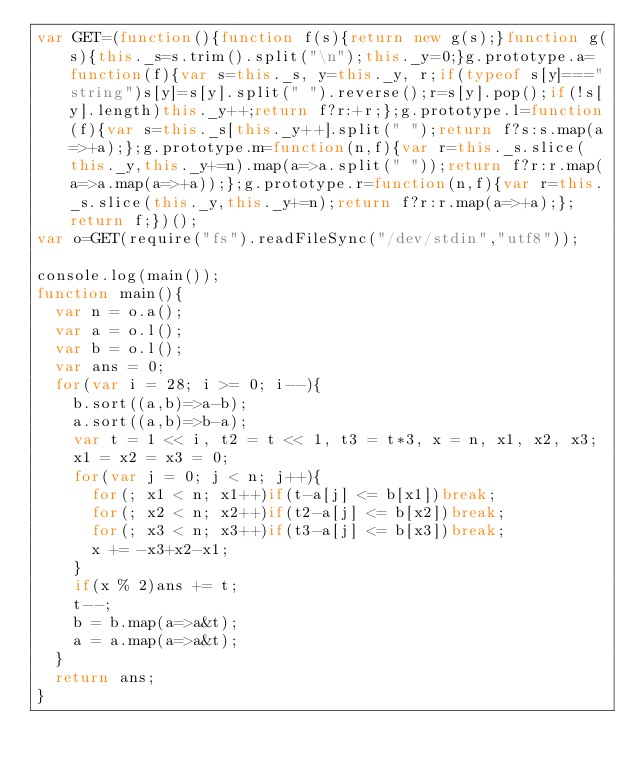Convert code to text. <code><loc_0><loc_0><loc_500><loc_500><_JavaScript_>var GET=(function(){function f(s){return new g(s);}function g(s){this._s=s.trim().split("\n");this._y=0;}g.prototype.a=function(f){var s=this._s, y=this._y, r;if(typeof s[y]==="string")s[y]=s[y].split(" ").reverse();r=s[y].pop();if(!s[y].length)this._y++;return f?r:+r;};g.prototype.l=function(f){var s=this._s[this._y++].split(" ");return f?s:s.map(a=>+a);};g.prototype.m=function(n,f){var r=this._s.slice(this._y,this._y+=n).map(a=>a.split(" "));return f?r:r.map(a=>a.map(a=>+a));};g.prototype.r=function(n,f){var r=this._s.slice(this._y,this._y+=n);return f?r:r.map(a=>+a);};return f;})();
var o=GET(require("fs").readFileSync("/dev/stdin","utf8"));

console.log(main());
function main(){
  var n = o.a();
  var a = o.l();
  var b = o.l();
  var ans = 0;
  for(var i = 28; i >= 0; i--){
    b.sort((a,b)=>a-b);
    a.sort((a,b)=>b-a);
    var t = 1 << i, t2 = t << 1, t3 = t*3, x = n, x1, x2, x3;
    x1 = x2 = x3 = 0;
    for(var j = 0; j < n; j++){
      for(; x1 < n; x1++)if(t-a[j] <= b[x1])break;
      for(; x2 < n; x2++)if(t2-a[j] <= b[x2])break;
      for(; x3 < n; x3++)if(t3-a[j] <= b[x3])break;
      x += -x3+x2-x1;
    }
    if(x % 2)ans += t;
    t--;
    b = b.map(a=>a&t);
    a = a.map(a=>a&t);
  }
  return ans;
}</code> 